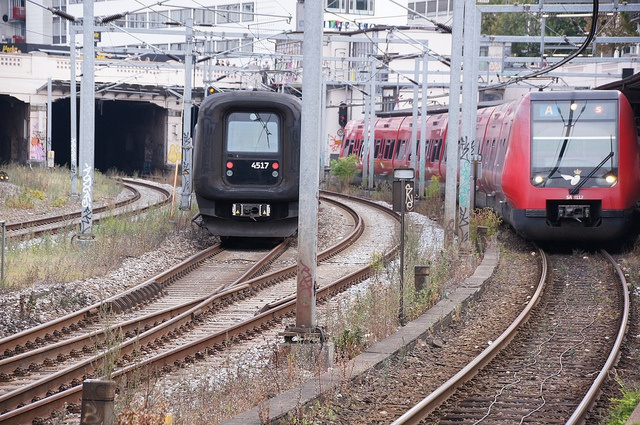Describe the objects in this image and their specific colors. I can see train in gray, black, and darkgray tones, train in gray, black, and darkgray tones, traffic light in gray, black, and purple tones, and traffic light in gray, black, and darkblue tones in this image. 